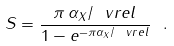<formula> <loc_0><loc_0><loc_500><loc_500>S = \frac { \pi \, \alpha _ { X } / \ v r e l } { 1 - e ^ { - \pi \alpha _ { X } / \ v r e l } } \ .</formula> 